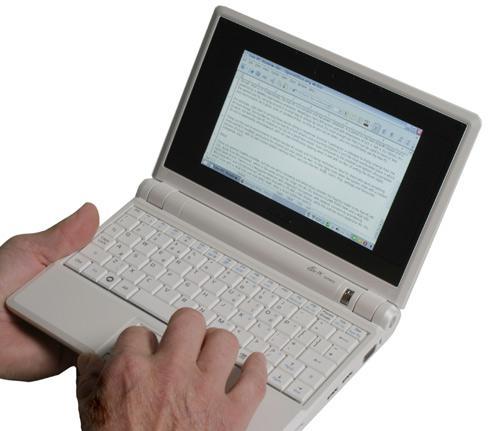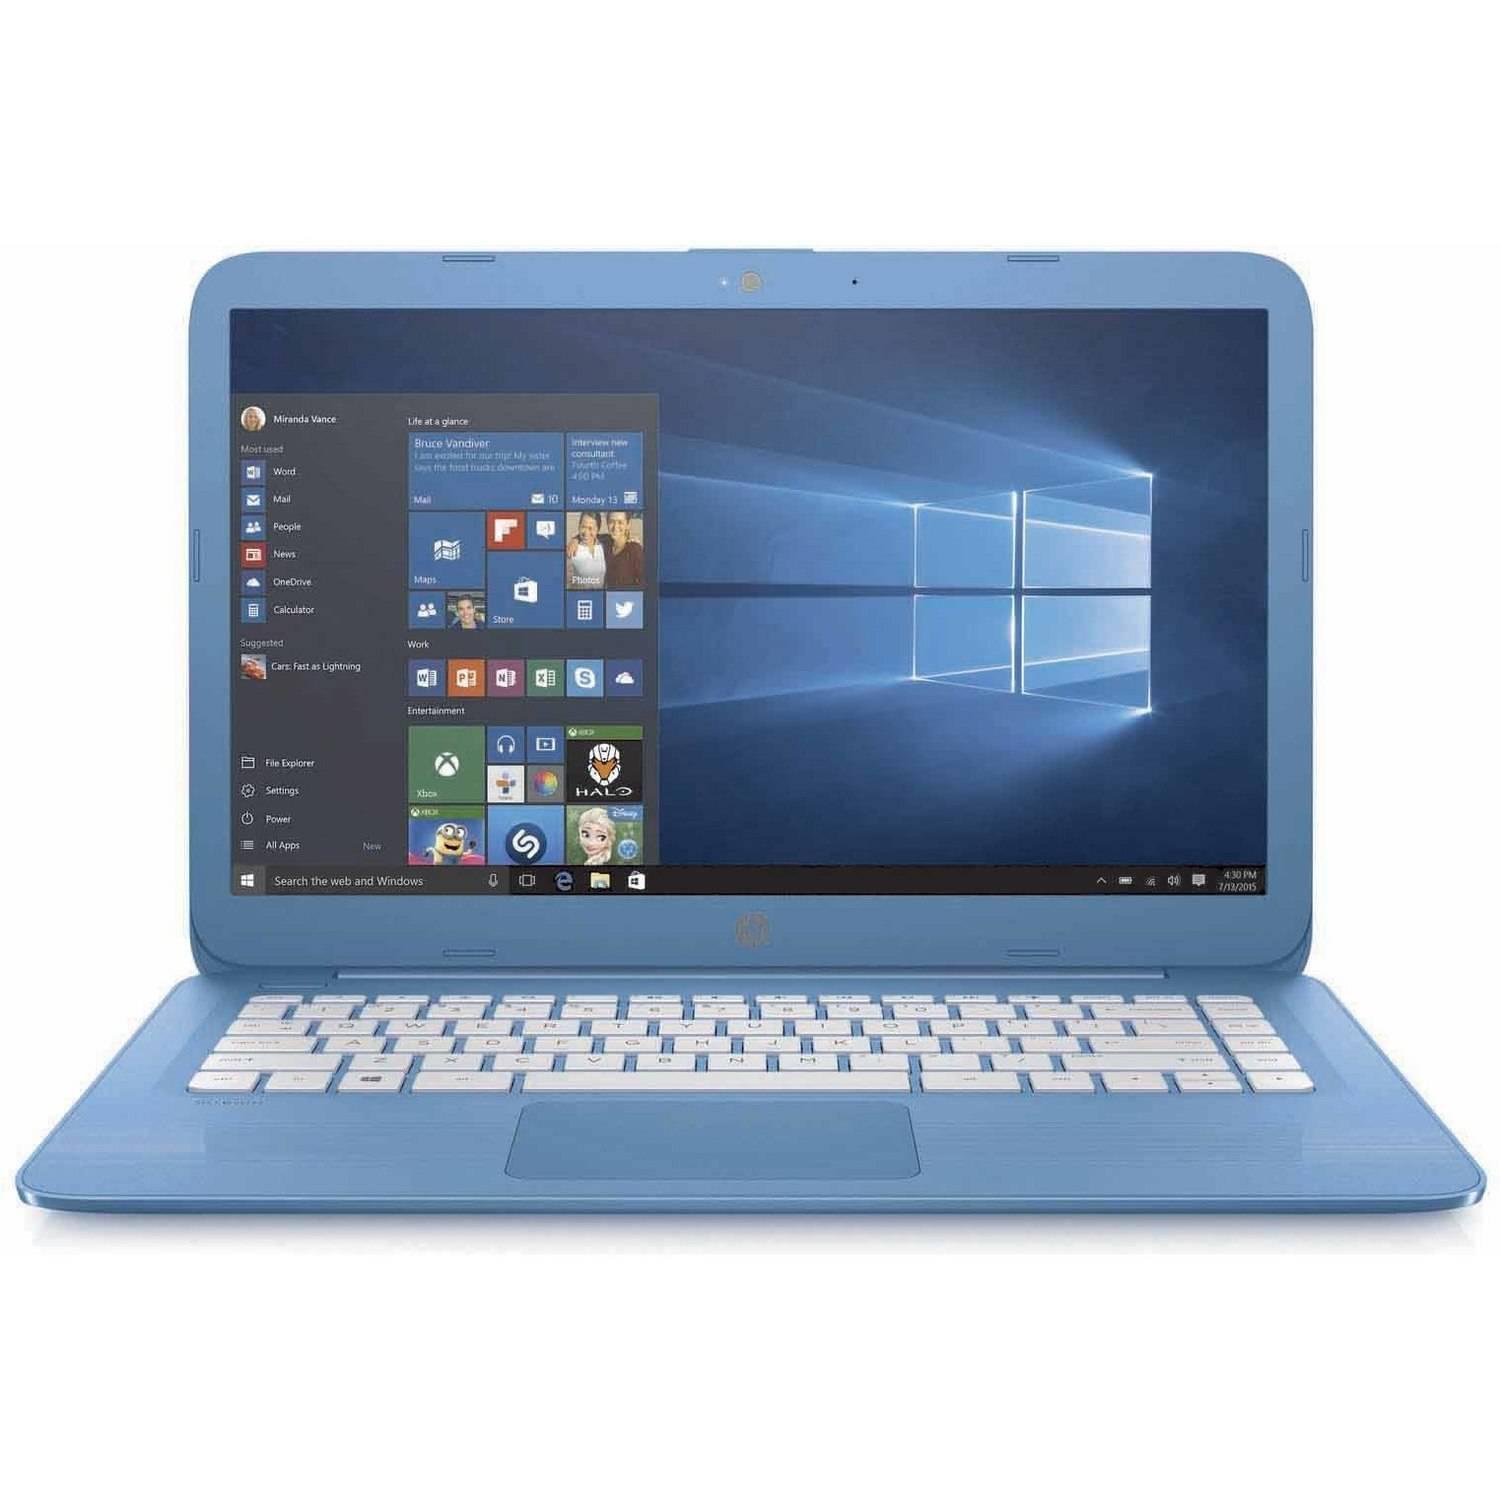The first image is the image on the left, the second image is the image on the right. For the images shown, is this caption "The keyboard in the image on the left is black." true? Answer yes or no. No. The first image is the image on the left, the second image is the image on the right. Analyze the images presented: Is the assertion "One open laptop faces straight forward, and the other is turned at an angle but not held by a hand." valid? Answer yes or no. No. 